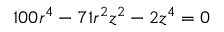Convert formula to latex. <formula><loc_0><loc_0><loc_500><loc_500>1 0 0 r ^ { 4 } - 7 1 r ^ { 2 } z ^ { 2 } - 2 z ^ { 4 } = 0</formula> 